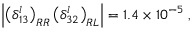Convert formula to latex. <formula><loc_0><loc_0><loc_500><loc_500>\left | \left ( \delta _ { 1 3 } ^ { l } \right ) _ { R R } \left ( \delta _ { 3 2 } ^ { l } \right ) _ { R L } \right | = 1 . 4 \times 1 0 ^ { - 5 } \, ,</formula> 